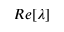<formula> <loc_0><loc_0><loc_500><loc_500>R e [ \lambda ]</formula> 